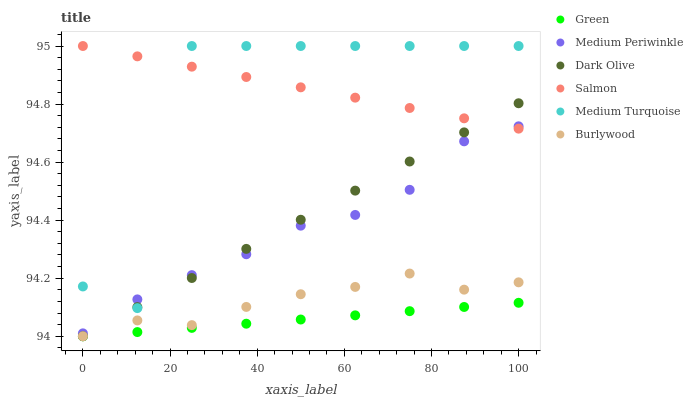Does Green have the minimum area under the curve?
Answer yes or no. Yes. Does Salmon have the maximum area under the curve?
Answer yes or no. Yes. Does Dark Olive have the minimum area under the curve?
Answer yes or no. No. Does Dark Olive have the maximum area under the curve?
Answer yes or no. No. Is Green the smoothest?
Answer yes or no. Yes. Is Medium Turquoise the roughest?
Answer yes or no. Yes. Is Salmon the smoothest?
Answer yes or no. No. Is Salmon the roughest?
Answer yes or no. No. Does Burlywood have the lowest value?
Answer yes or no. Yes. Does Salmon have the lowest value?
Answer yes or no. No. Does Medium Turquoise have the highest value?
Answer yes or no. Yes. Does Dark Olive have the highest value?
Answer yes or no. No. Is Green less than Medium Turquoise?
Answer yes or no. Yes. Is Medium Periwinkle greater than Green?
Answer yes or no. Yes. Does Green intersect Dark Olive?
Answer yes or no. Yes. Is Green less than Dark Olive?
Answer yes or no. No. Is Green greater than Dark Olive?
Answer yes or no. No. Does Green intersect Medium Turquoise?
Answer yes or no. No. 